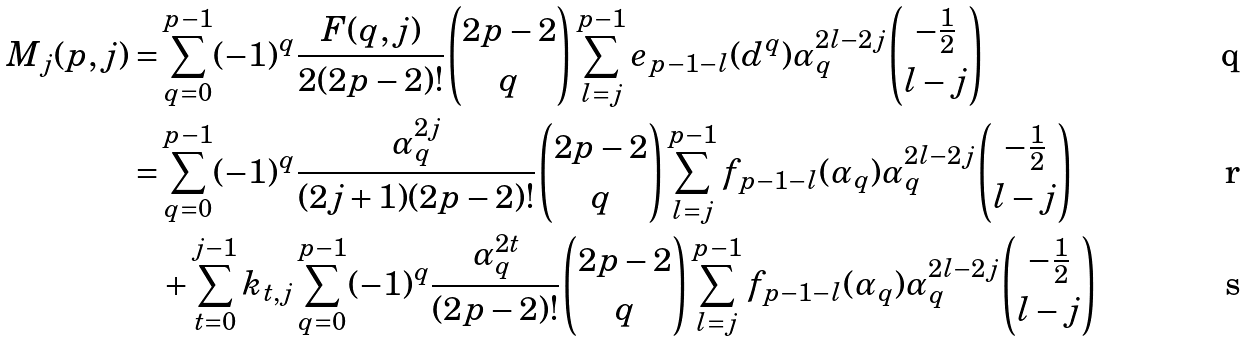Convert formula to latex. <formula><loc_0><loc_0><loc_500><loc_500>M _ { j } ( p , j ) = & \sum ^ { p - 1 } _ { q = 0 } ( - 1 ) ^ { q } \frac { F ( q , j ) } { 2 ( 2 p - 2 ) ! } \binom { 2 p - 2 } { q } \sum ^ { p - 1 } _ { l = j } e _ { p - 1 - l } ( d ^ { q } ) \alpha _ { q } ^ { 2 l - 2 j } \binom { - \frac { 1 } { 2 } } { l - j } \\ = & \sum ^ { p - 1 } _ { q = 0 } ( - 1 ) ^ { q } \frac { \alpha _ { q } ^ { 2 j } } { ( 2 j + 1 ) ( 2 p - 2 ) ! } \binom { 2 p - 2 } { q } \sum ^ { p - 1 } _ { l = j } f _ { p - 1 - l } ( \alpha _ { q } ) \alpha _ { q } ^ { 2 l - 2 j } \binom { - \frac { 1 } { 2 } } { l - j } \\ & + \sum ^ { j - 1 } _ { t = 0 } k _ { t , j } \sum ^ { p - 1 } _ { q = 0 } ( - 1 ) ^ { q } \frac { \alpha _ { q } ^ { 2 t } } { ( 2 p - 2 ) ! } \binom { 2 p - 2 } { q } \sum ^ { p - 1 } _ { l = j } f _ { p - 1 - l } ( \alpha _ { q } ) \alpha _ { q } ^ { 2 l - 2 j } \binom { - \frac { 1 } { 2 } } { l - j }</formula> 